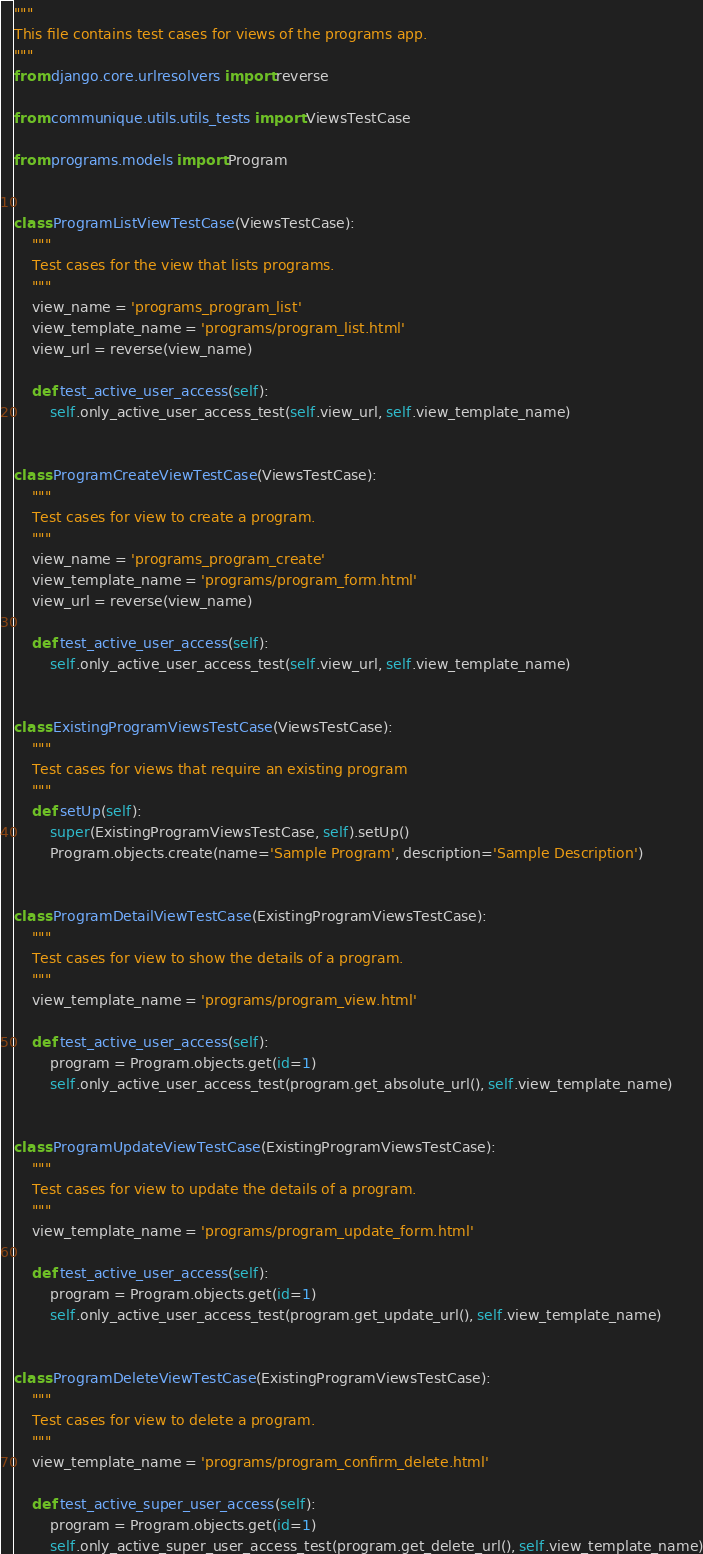<code> <loc_0><loc_0><loc_500><loc_500><_Python_>"""
This file contains test cases for views of the programs app.
"""
from django.core.urlresolvers import reverse

from communique.utils.utils_tests import ViewsTestCase

from programs.models import Program


class ProgramListViewTestCase(ViewsTestCase):
    """
    Test cases for the view that lists programs.
    """
    view_name = 'programs_program_list'
    view_template_name = 'programs/program_list.html'
    view_url = reverse(view_name)

    def test_active_user_access(self):
        self.only_active_user_access_test(self.view_url, self.view_template_name)


class ProgramCreateViewTestCase(ViewsTestCase):
    """
    Test cases for view to create a program.
    """
    view_name = 'programs_program_create'
    view_template_name = 'programs/program_form.html'
    view_url = reverse(view_name)

    def test_active_user_access(self):
        self.only_active_user_access_test(self.view_url, self.view_template_name)


class ExistingProgramViewsTestCase(ViewsTestCase):
    """
    Test cases for views that require an existing program
    """
    def setUp(self):
        super(ExistingProgramViewsTestCase, self).setUp()
        Program.objects.create(name='Sample Program', description='Sample Description')


class ProgramDetailViewTestCase(ExistingProgramViewsTestCase):
    """
    Test cases for view to show the details of a program.
    """
    view_template_name = 'programs/program_view.html'

    def test_active_user_access(self):
        program = Program.objects.get(id=1)
        self.only_active_user_access_test(program.get_absolute_url(), self.view_template_name)


class ProgramUpdateViewTestCase(ExistingProgramViewsTestCase):
    """
    Test cases for view to update the details of a program.
    """
    view_template_name = 'programs/program_update_form.html'

    def test_active_user_access(self):
        program = Program.objects.get(id=1)
        self.only_active_user_access_test(program.get_update_url(), self.view_template_name)


class ProgramDeleteViewTestCase(ExistingProgramViewsTestCase):
    """
    Test cases for view to delete a program.
    """
    view_template_name = 'programs/program_confirm_delete.html'

    def test_active_super_user_access(self):
        program = Program.objects.get(id=1)
        self.only_active_super_user_access_test(program.get_delete_url(), self.view_template_name)

</code> 